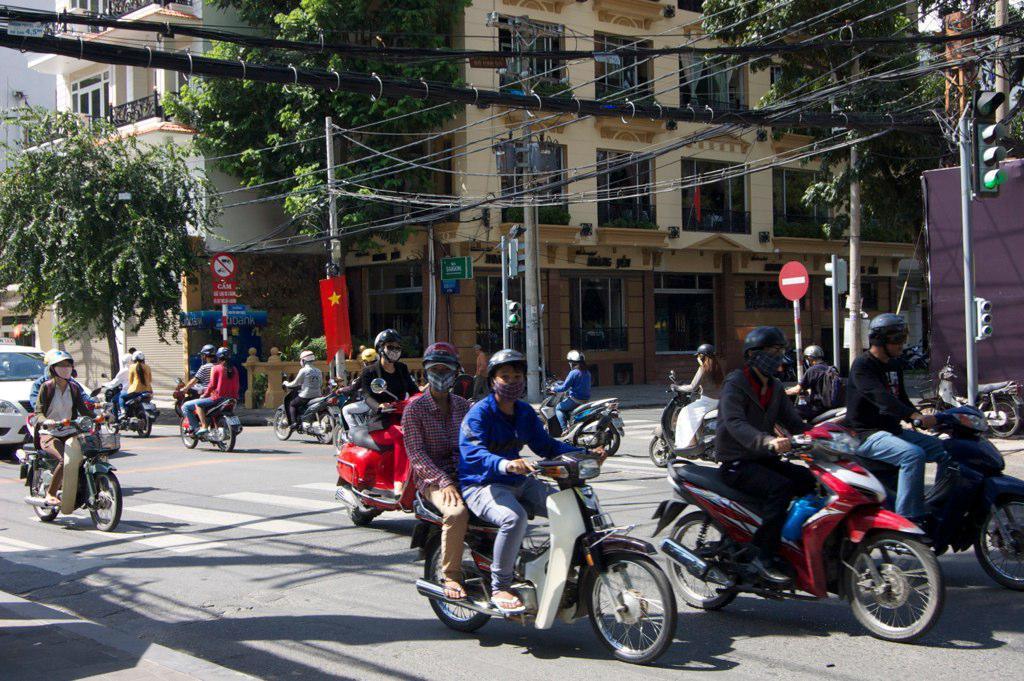Could you give a brief overview of what you see in this image? There is a road on which there are different types of vehicles riding on it and man who is riding is having a helmet on his head and we can see a sign board and in the left side we can see a tree and in the background we can see building which have windows and curtains in it and on the top we can see wires and on the right side we can see traffic signal pole ,on the left side we can see a flag,on the road we can see zebra crossing,on the right side we can see cover in the bike. 